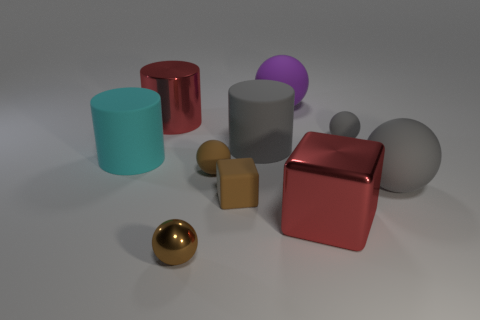Subtract all cyan blocks. How many brown balls are left? 2 Subtract 2 balls. How many balls are left? 3 Subtract all matte cylinders. How many cylinders are left? 1 Subtract all purple balls. How many balls are left? 4 Subtract all cylinders. How many objects are left? 7 Subtract all blue cylinders. Subtract all purple blocks. How many cylinders are left? 3 Add 4 big red cubes. How many big red cubes exist? 5 Subtract 0 yellow blocks. How many objects are left? 10 Subtract all small brown blocks. Subtract all big yellow rubber cubes. How many objects are left? 9 Add 5 big gray balls. How many big gray balls are left? 6 